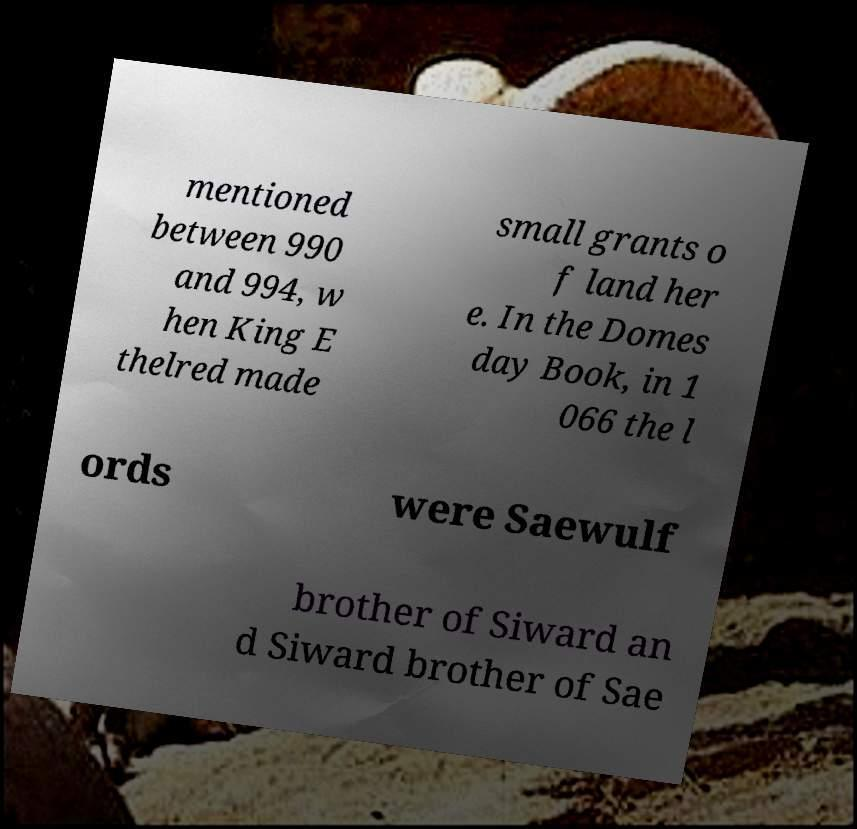What messages or text are displayed in this image? I need them in a readable, typed format. mentioned between 990 and 994, w hen King E thelred made small grants o f land her e. In the Domes day Book, in 1 066 the l ords were Saewulf brother of Siward an d Siward brother of Sae 